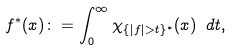<formula> <loc_0><loc_0><loc_500><loc_500>f ^ { * } ( x ) \colon = \int _ { 0 } ^ { \infty } \chi _ { \{ | f | > t \} ^ { * } } ( x ) \ d t ,</formula> 